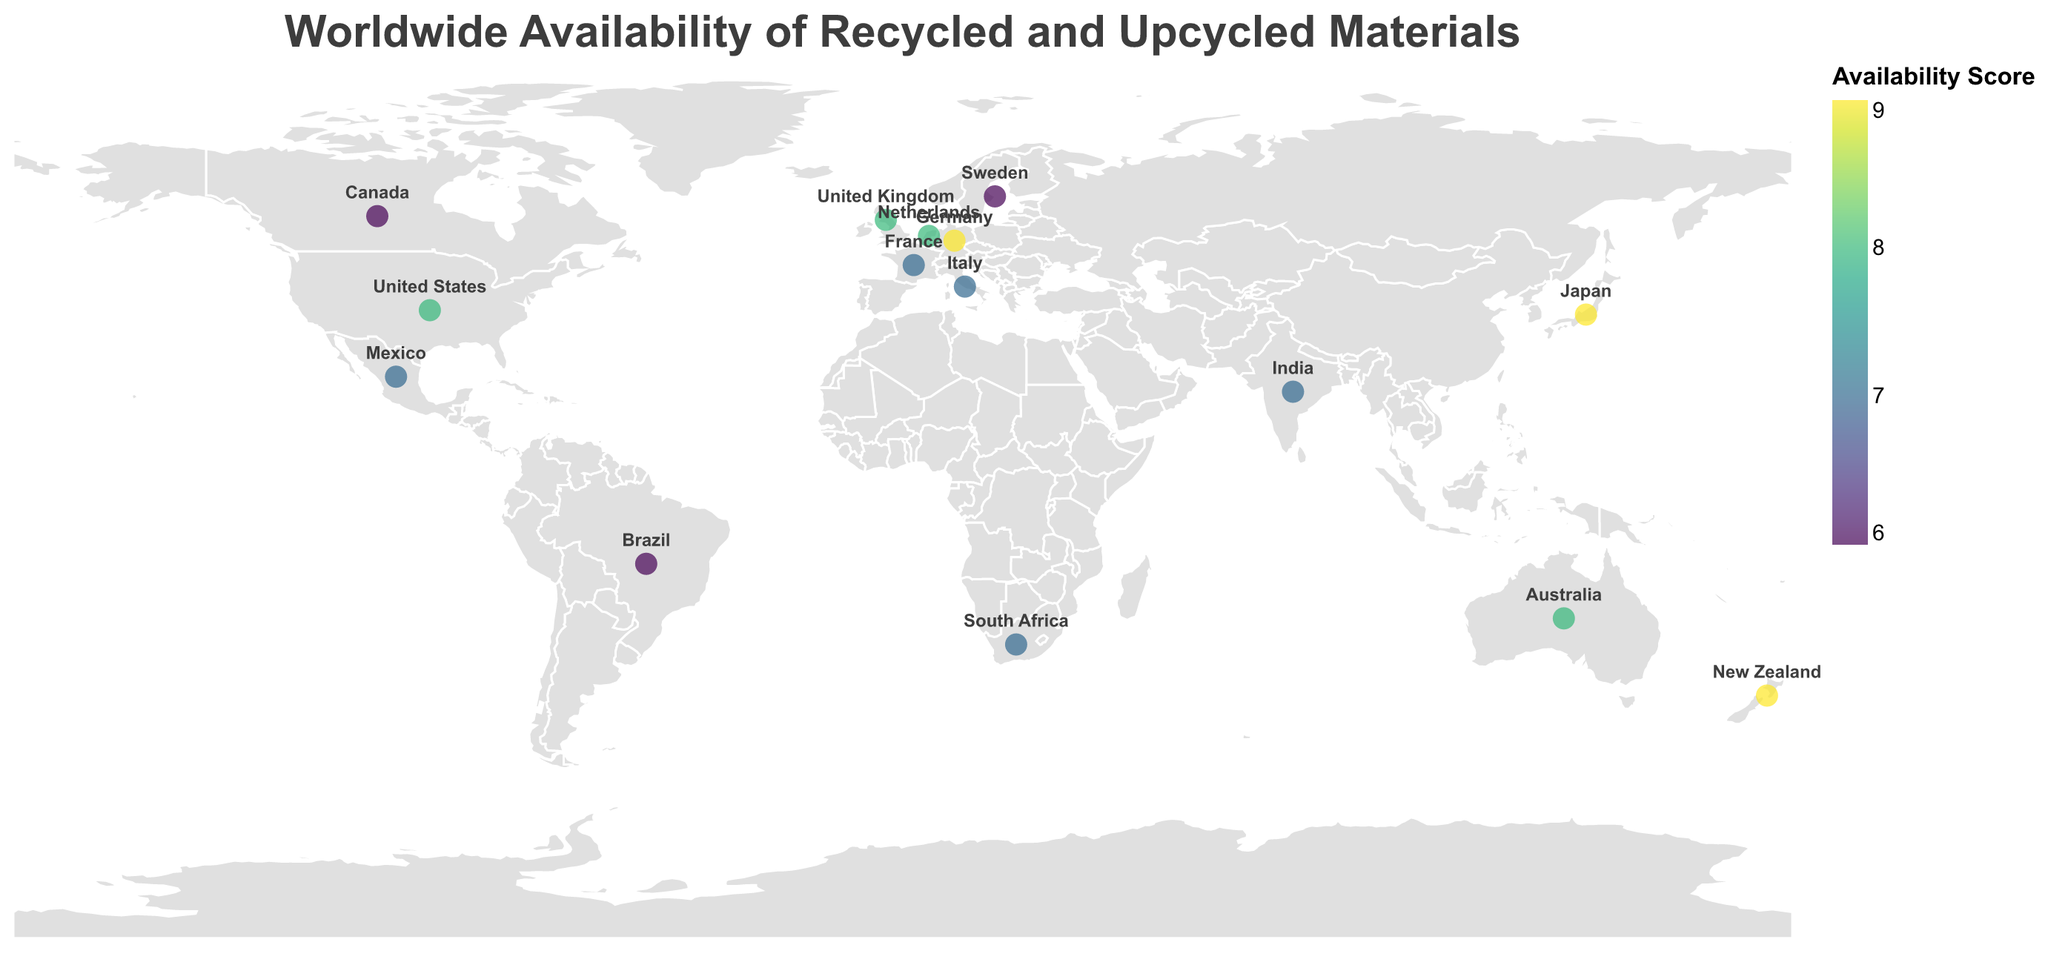What country has the highest availability score for recycled paper? The figure shows that Japan has a recycled paper availability score of 9, which is visually indicated by a color correlated with high availability.
Answer: Japan Which country specializes in recycled fabric? The tooltip or labels on the plot indicate that France specializes in recycled fabric.
Answer: France How does the availability score of recycled metal in Germany compare to recycled wool in New Zealand? Recycled metal in Germany and recycled wool in New Zealand both have an availability score of 9.
Answer: They are equal Which region is noted for its use of ocean plastic? The map tooltip for Australia indicates a specialty in recycled plastic, particularly ocean plastic.
Answer: Australia What is the average availability score of materials in the Americas (United States, Canada, Brazil, Mexico)? United States (8), Canada (6), Brazil (6), and Mexico (7) have respective scores. The average is (8 + 6 + 6 + 7) / 4 = 6.75.
Answer: 6.75 Which European country has the highest availability score, and for which material? Among European countries, Germany and the Netherlands have an availability score of 9 and 8, respectively. Hence, Germany has the highest score for recycled metal.
Answer: Germany, recycled metal Compare the availability score of recycled glass in Italy to upcycled shipping containers in the United Kingdom. Which one has a higher score? Recycled glass in Italy has a score of 7 while upcycled shipping containers in the UK have a score of 8.
Answer: United Kingdom What material is most popular in the southern hemisphere according to the plot, and which country specializes in it? By checking the countries in the southern hemisphere such as Brazil, Australia, South Africa, and New Zealand, the highest availability score is 9 for recycled wool in New Zealand.
Answer: Recycled wool, New Zealand Identify the specialty of upcycled rubber and the country associated with it. The tooltip for South Africa indicates that the specialty of upcycled rubber is tire rubber.
Answer: South Africa How many countries have an availability score of 7 for their materials? By checking the colored scores on the map, Italy (7), India (7), South Africa (7), Mexico (7), and France (7) each have an availability score of 7, totaling 5 countries.
Answer: 5 